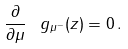<formula> <loc_0><loc_0><loc_500><loc_500>\frac { \partial } { \partial \mu } \, \ g _ { \mu ^ { - } } ( z ) = 0 \, .</formula> 